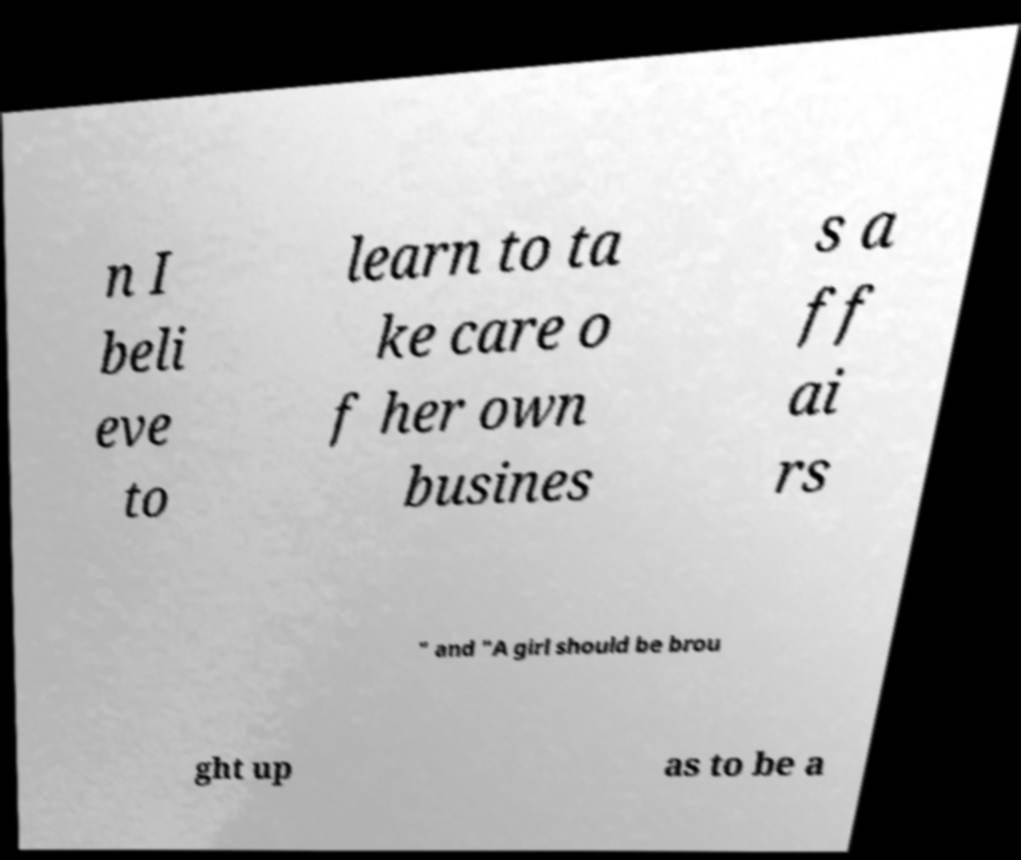Could you assist in decoding the text presented in this image and type it out clearly? n I beli eve to learn to ta ke care o f her own busines s a ff ai rs " and "A girl should be brou ght up as to be a 